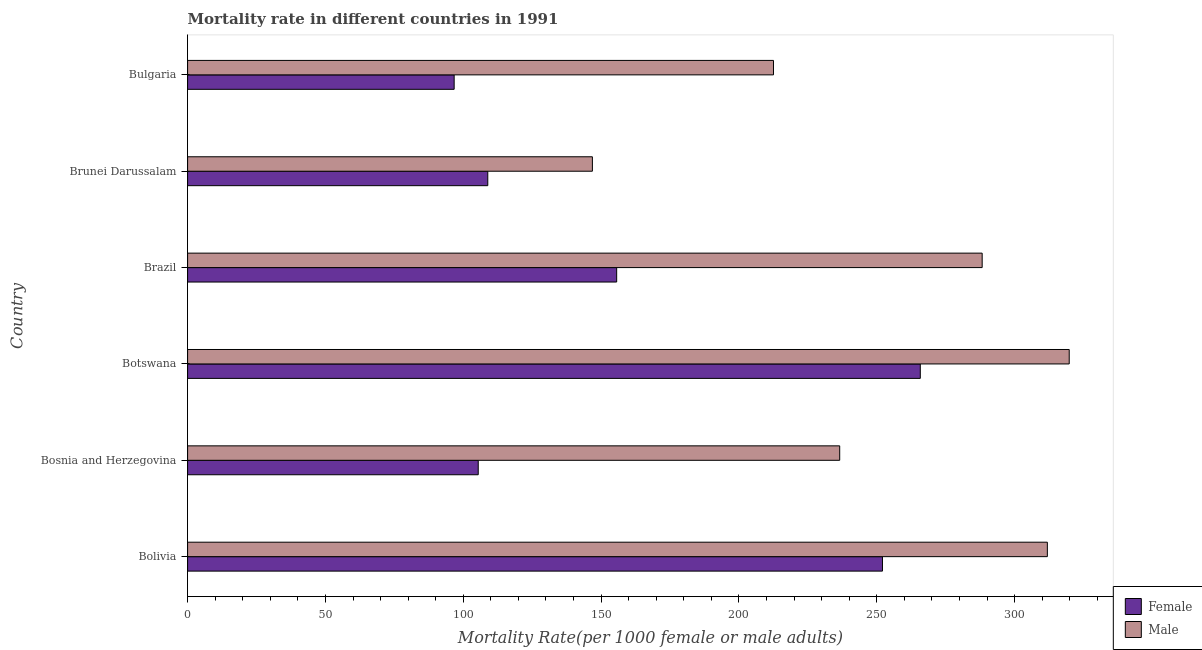How many different coloured bars are there?
Offer a terse response. 2. Are the number of bars per tick equal to the number of legend labels?
Provide a short and direct response. Yes. Are the number of bars on each tick of the Y-axis equal?
Your response must be concise. Yes. How many bars are there on the 1st tick from the top?
Offer a very short reply. 2. How many bars are there on the 1st tick from the bottom?
Your answer should be compact. 2. What is the label of the 6th group of bars from the top?
Offer a terse response. Bolivia. In how many cases, is the number of bars for a given country not equal to the number of legend labels?
Ensure brevity in your answer.  0. What is the male mortality rate in Bosnia and Herzegovina?
Offer a terse response. 236.55. Across all countries, what is the maximum female mortality rate?
Keep it short and to the point. 265.79. Across all countries, what is the minimum female mortality rate?
Offer a terse response. 96.69. In which country was the female mortality rate maximum?
Give a very brief answer. Botswana. In which country was the female mortality rate minimum?
Your answer should be compact. Bulgaria. What is the total male mortality rate in the graph?
Offer a terse response. 1515.84. What is the difference between the female mortality rate in Bolivia and that in Brazil?
Your answer should be compact. 96.42. What is the difference between the male mortality rate in Bulgaria and the female mortality rate in Bosnia and Herzegovina?
Provide a succinct answer. 107.1. What is the average male mortality rate per country?
Provide a succinct answer. 252.64. What is the difference between the female mortality rate and male mortality rate in Brazil?
Your answer should be compact. -132.59. In how many countries, is the female mortality rate greater than 130 ?
Provide a short and direct response. 3. What is the ratio of the female mortality rate in Brunei Darussalam to that in Bulgaria?
Give a very brief answer. 1.13. Is the male mortality rate in Botswana less than that in Brazil?
Give a very brief answer. No. Is the difference between the male mortality rate in Bosnia and Herzegovina and Bulgaria greater than the difference between the female mortality rate in Bosnia and Herzegovina and Bulgaria?
Ensure brevity in your answer.  Yes. What is the difference between the highest and the second highest female mortality rate?
Give a very brief answer. 13.72. What is the difference between the highest and the lowest female mortality rate?
Offer a terse response. 169.09. In how many countries, is the male mortality rate greater than the average male mortality rate taken over all countries?
Offer a very short reply. 3. What does the 1st bar from the bottom in Botswana represents?
Ensure brevity in your answer.  Female. How many bars are there?
Your response must be concise. 12. Are all the bars in the graph horizontal?
Your response must be concise. Yes. How many countries are there in the graph?
Your answer should be very brief. 6. What is the difference between two consecutive major ticks on the X-axis?
Keep it short and to the point. 50. Does the graph contain any zero values?
Offer a very short reply. No. Where does the legend appear in the graph?
Keep it short and to the point. Bottom right. How many legend labels are there?
Make the answer very short. 2. How are the legend labels stacked?
Your answer should be compact. Vertical. What is the title of the graph?
Give a very brief answer. Mortality rate in different countries in 1991. What is the label or title of the X-axis?
Your response must be concise. Mortality Rate(per 1000 female or male adults). What is the label or title of the Y-axis?
Give a very brief answer. Country. What is the Mortality Rate(per 1000 female or male adults) of Female in Bolivia?
Your answer should be very brief. 252.06. What is the Mortality Rate(per 1000 female or male adults) of Male in Bolivia?
Offer a very short reply. 311.88. What is the Mortality Rate(per 1000 female or male adults) of Female in Bosnia and Herzegovina?
Your answer should be compact. 105.43. What is the Mortality Rate(per 1000 female or male adults) of Male in Bosnia and Herzegovina?
Offer a very short reply. 236.55. What is the Mortality Rate(per 1000 female or male adults) of Female in Botswana?
Make the answer very short. 265.79. What is the Mortality Rate(per 1000 female or male adults) in Male in Botswana?
Provide a short and direct response. 319.81. What is the Mortality Rate(per 1000 female or male adults) of Female in Brazil?
Your response must be concise. 155.65. What is the Mortality Rate(per 1000 female or male adults) in Male in Brazil?
Your answer should be compact. 288.23. What is the Mortality Rate(per 1000 female or male adults) of Female in Brunei Darussalam?
Offer a terse response. 108.89. What is the Mortality Rate(per 1000 female or male adults) of Male in Brunei Darussalam?
Make the answer very short. 146.84. What is the Mortality Rate(per 1000 female or male adults) of Female in Bulgaria?
Provide a short and direct response. 96.69. What is the Mortality Rate(per 1000 female or male adults) in Male in Bulgaria?
Your answer should be very brief. 212.53. Across all countries, what is the maximum Mortality Rate(per 1000 female or male adults) in Female?
Provide a succinct answer. 265.79. Across all countries, what is the maximum Mortality Rate(per 1000 female or male adults) in Male?
Give a very brief answer. 319.81. Across all countries, what is the minimum Mortality Rate(per 1000 female or male adults) of Female?
Your response must be concise. 96.69. Across all countries, what is the minimum Mortality Rate(per 1000 female or male adults) of Male?
Ensure brevity in your answer.  146.84. What is the total Mortality Rate(per 1000 female or male adults) in Female in the graph?
Provide a short and direct response. 984.52. What is the total Mortality Rate(per 1000 female or male adults) of Male in the graph?
Your answer should be very brief. 1515.85. What is the difference between the Mortality Rate(per 1000 female or male adults) of Female in Bolivia and that in Bosnia and Herzegovina?
Give a very brief answer. 146.63. What is the difference between the Mortality Rate(per 1000 female or male adults) of Male in Bolivia and that in Bosnia and Herzegovina?
Ensure brevity in your answer.  75.33. What is the difference between the Mortality Rate(per 1000 female or male adults) in Female in Bolivia and that in Botswana?
Offer a terse response. -13.72. What is the difference between the Mortality Rate(per 1000 female or male adults) of Male in Bolivia and that in Botswana?
Give a very brief answer. -7.93. What is the difference between the Mortality Rate(per 1000 female or male adults) of Female in Bolivia and that in Brazil?
Give a very brief answer. 96.42. What is the difference between the Mortality Rate(per 1000 female or male adults) in Male in Bolivia and that in Brazil?
Offer a terse response. 23.64. What is the difference between the Mortality Rate(per 1000 female or male adults) of Female in Bolivia and that in Brunei Darussalam?
Your answer should be compact. 143.18. What is the difference between the Mortality Rate(per 1000 female or male adults) of Male in Bolivia and that in Brunei Darussalam?
Offer a very short reply. 165.04. What is the difference between the Mortality Rate(per 1000 female or male adults) in Female in Bolivia and that in Bulgaria?
Make the answer very short. 155.37. What is the difference between the Mortality Rate(per 1000 female or male adults) in Male in Bolivia and that in Bulgaria?
Provide a short and direct response. 99.35. What is the difference between the Mortality Rate(per 1000 female or male adults) of Female in Bosnia and Herzegovina and that in Botswana?
Make the answer very short. -160.36. What is the difference between the Mortality Rate(per 1000 female or male adults) of Male in Bosnia and Herzegovina and that in Botswana?
Offer a very short reply. -83.26. What is the difference between the Mortality Rate(per 1000 female or male adults) in Female in Bosnia and Herzegovina and that in Brazil?
Provide a short and direct response. -50.22. What is the difference between the Mortality Rate(per 1000 female or male adults) in Male in Bosnia and Herzegovina and that in Brazil?
Keep it short and to the point. -51.68. What is the difference between the Mortality Rate(per 1000 female or male adults) of Female in Bosnia and Herzegovina and that in Brunei Darussalam?
Give a very brief answer. -3.46. What is the difference between the Mortality Rate(per 1000 female or male adults) of Male in Bosnia and Herzegovina and that in Brunei Darussalam?
Offer a very short reply. 89.71. What is the difference between the Mortality Rate(per 1000 female or male adults) in Female in Bosnia and Herzegovina and that in Bulgaria?
Provide a succinct answer. 8.74. What is the difference between the Mortality Rate(per 1000 female or male adults) in Male in Bosnia and Herzegovina and that in Bulgaria?
Provide a succinct answer. 24.02. What is the difference between the Mortality Rate(per 1000 female or male adults) of Female in Botswana and that in Brazil?
Give a very brief answer. 110.14. What is the difference between the Mortality Rate(per 1000 female or male adults) of Male in Botswana and that in Brazil?
Provide a succinct answer. 31.58. What is the difference between the Mortality Rate(per 1000 female or male adults) of Female in Botswana and that in Brunei Darussalam?
Your answer should be compact. 156.9. What is the difference between the Mortality Rate(per 1000 female or male adults) of Male in Botswana and that in Brunei Darussalam?
Your response must be concise. 172.97. What is the difference between the Mortality Rate(per 1000 female or male adults) of Female in Botswana and that in Bulgaria?
Make the answer very short. 169.09. What is the difference between the Mortality Rate(per 1000 female or male adults) of Male in Botswana and that in Bulgaria?
Provide a short and direct response. 107.28. What is the difference between the Mortality Rate(per 1000 female or male adults) in Female in Brazil and that in Brunei Darussalam?
Ensure brevity in your answer.  46.76. What is the difference between the Mortality Rate(per 1000 female or male adults) of Male in Brazil and that in Brunei Darussalam?
Give a very brief answer. 141.39. What is the difference between the Mortality Rate(per 1000 female or male adults) in Female in Brazil and that in Bulgaria?
Ensure brevity in your answer.  58.95. What is the difference between the Mortality Rate(per 1000 female or male adults) in Male in Brazil and that in Bulgaria?
Offer a terse response. 75.7. What is the difference between the Mortality Rate(per 1000 female or male adults) in Female in Brunei Darussalam and that in Bulgaria?
Ensure brevity in your answer.  12.2. What is the difference between the Mortality Rate(per 1000 female or male adults) of Male in Brunei Darussalam and that in Bulgaria?
Give a very brief answer. -65.69. What is the difference between the Mortality Rate(per 1000 female or male adults) in Female in Bolivia and the Mortality Rate(per 1000 female or male adults) in Male in Bosnia and Herzegovina?
Your answer should be compact. 15.51. What is the difference between the Mortality Rate(per 1000 female or male adults) in Female in Bolivia and the Mortality Rate(per 1000 female or male adults) in Male in Botswana?
Provide a short and direct response. -67.75. What is the difference between the Mortality Rate(per 1000 female or male adults) of Female in Bolivia and the Mortality Rate(per 1000 female or male adults) of Male in Brazil?
Your response must be concise. -36.17. What is the difference between the Mortality Rate(per 1000 female or male adults) of Female in Bolivia and the Mortality Rate(per 1000 female or male adults) of Male in Brunei Darussalam?
Offer a very short reply. 105.22. What is the difference between the Mortality Rate(per 1000 female or male adults) of Female in Bolivia and the Mortality Rate(per 1000 female or male adults) of Male in Bulgaria?
Your answer should be compact. 39.54. What is the difference between the Mortality Rate(per 1000 female or male adults) in Female in Bosnia and Herzegovina and the Mortality Rate(per 1000 female or male adults) in Male in Botswana?
Your answer should be compact. -214.38. What is the difference between the Mortality Rate(per 1000 female or male adults) of Female in Bosnia and Herzegovina and the Mortality Rate(per 1000 female or male adults) of Male in Brazil?
Offer a terse response. -182.8. What is the difference between the Mortality Rate(per 1000 female or male adults) in Female in Bosnia and Herzegovina and the Mortality Rate(per 1000 female or male adults) in Male in Brunei Darussalam?
Make the answer very short. -41.41. What is the difference between the Mortality Rate(per 1000 female or male adults) in Female in Bosnia and Herzegovina and the Mortality Rate(per 1000 female or male adults) in Male in Bulgaria?
Offer a terse response. -107.1. What is the difference between the Mortality Rate(per 1000 female or male adults) of Female in Botswana and the Mortality Rate(per 1000 female or male adults) of Male in Brazil?
Your answer should be very brief. -22.44. What is the difference between the Mortality Rate(per 1000 female or male adults) of Female in Botswana and the Mortality Rate(per 1000 female or male adults) of Male in Brunei Darussalam?
Your answer should be very brief. 118.95. What is the difference between the Mortality Rate(per 1000 female or male adults) in Female in Botswana and the Mortality Rate(per 1000 female or male adults) in Male in Bulgaria?
Your answer should be compact. 53.26. What is the difference between the Mortality Rate(per 1000 female or male adults) in Female in Brazil and the Mortality Rate(per 1000 female or male adults) in Male in Brunei Darussalam?
Give a very brief answer. 8.81. What is the difference between the Mortality Rate(per 1000 female or male adults) of Female in Brazil and the Mortality Rate(per 1000 female or male adults) of Male in Bulgaria?
Ensure brevity in your answer.  -56.88. What is the difference between the Mortality Rate(per 1000 female or male adults) in Female in Brunei Darussalam and the Mortality Rate(per 1000 female or male adults) in Male in Bulgaria?
Offer a very short reply. -103.64. What is the average Mortality Rate(per 1000 female or male adults) of Female per country?
Offer a terse response. 164.09. What is the average Mortality Rate(per 1000 female or male adults) of Male per country?
Your answer should be very brief. 252.64. What is the difference between the Mortality Rate(per 1000 female or male adults) of Female and Mortality Rate(per 1000 female or male adults) of Male in Bolivia?
Make the answer very short. -59.81. What is the difference between the Mortality Rate(per 1000 female or male adults) in Female and Mortality Rate(per 1000 female or male adults) in Male in Bosnia and Herzegovina?
Your answer should be compact. -131.12. What is the difference between the Mortality Rate(per 1000 female or male adults) of Female and Mortality Rate(per 1000 female or male adults) of Male in Botswana?
Offer a very short reply. -54.02. What is the difference between the Mortality Rate(per 1000 female or male adults) of Female and Mortality Rate(per 1000 female or male adults) of Male in Brazil?
Provide a succinct answer. -132.59. What is the difference between the Mortality Rate(per 1000 female or male adults) of Female and Mortality Rate(per 1000 female or male adults) of Male in Brunei Darussalam?
Offer a terse response. -37.95. What is the difference between the Mortality Rate(per 1000 female or male adults) of Female and Mortality Rate(per 1000 female or male adults) of Male in Bulgaria?
Ensure brevity in your answer.  -115.83. What is the ratio of the Mortality Rate(per 1000 female or male adults) of Female in Bolivia to that in Bosnia and Herzegovina?
Make the answer very short. 2.39. What is the ratio of the Mortality Rate(per 1000 female or male adults) of Male in Bolivia to that in Bosnia and Herzegovina?
Provide a short and direct response. 1.32. What is the ratio of the Mortality Rate(per 1000 female or male adults) in Female in Bolivia to that in Botswana?
Your answer should be very brief. 0.95. What is the ratio of the Mortality Rate(per 1000 female or male adults) of Male in Bolivia to that in Botswana?
Your answer should be compact. 0.98. What is the ratio of the Mortality Rate(per 1000 female or male adults) of Female in Bolivia to that in Brazil?
Your answer should be compact. 1.62. What is the ratio of the Mortality Rate(per 1000 female or male adults) in Male in Bolivia to that in Brazil?
Ensure brevity in your answer.  1.08. What is the ratio of the Mortality Rate(per 1000 female or male adults) of Female in Bolivia to that in Brunei Darussalam?
Ensure brevity in your answer.  2.31. What is the ratio of the Mortality Rate(per 1000 female or male adults) in Male in Bolivia to that in Brunei Darussalam?
Provide a short and direct response. 2.12. What is the ratio of the Mortality Rate(per 1000 female or male adults) in Female in Bolivia to that in Bulgaria?
Make the answer very short. 2.61. What is the ratio of the Mortality Rate(per 1000 female or male adults) of Male in Bolivia to that in Bulgaria?
Provide a short and direct response. 1.47. What is the ratio of the Mortality Rate(per 1000 female or male adults) of Female in Bosnia and Herzegovina to that in Botswana?
Your response must be concise. 0.4. What is the ratio of the Mortality Rate(per 1000 female or male adults) in Male in Bosnia and Herzegovina to that in Botswana?
Make the answer very short. 0.74. What is the ratio of the Mortality Rate(per 1000 female or male adults) of Female in Bosnia and Herzegovina to that in Brazil?
Your answer should be compact. 0.68. What is the ratio of the Mortality Rate(per 1000 female or male adults) of Male in Bosnia and Herzegovina to that in Brazil?
Your response must be concise. 0.82. What is the ratio of the Mortality Rate(per 1000 female or male adults) in Female in Bosnia and Herzegovina to that in Brunei Darussalam?
Keep it short and to the point. 0.97. What is the ratio of the Mortality Rate(per 1000 female or male adults) of Male in Bosnia and Herzegovina to that in Brunei Darussalam?
Offer a very short reply. 1.61. What is the ratio of the Mortality Rate(per 1000 female or male adults) of Female in Bosnia and Herzegovina to that in Bulgaria?
Offer a terse response. 1.09. What is the ratio of the Mortality Rate(per 1000 female or male adults) of Male in Bosnia and Herzegovina to that in Bulgaria?
Your answer should be very brief. 1.11. What is the ratio of the Mortality Rate(per 1000 female or male adults) of Female in Botswana to that in Brazil?
Make the answer very short. 1.71. What is the ratio of the Mortality Rate(per 1000 female or male adults) in Male in Botswana to that in Brazil?
Give a very brief answer. 1.11. What is the ratio of the Mortality Rate(per 1000 female or male adults) in Female in Botswana to that in Brunei Darussalam?
Ensure brevity in your answer.  2.44. What is the ratio of the Mortality Rate(per 1000 female or male adults) of Male in Botswana to that in Brunei Darussalam?
Your answer should be very brief. 2.18. What is the ratio of the Mortality Rate(per 1000 female or male adults) of Female in Botswana to that in Bulgaria?
Keep it short and to the point. 2.75. What is the ratio of the Mortality Rate(per 1000 female or male adults) in Male in Botswana to that in Bulgaria?
Provide a succinct answer. 1.5. What is the ratio of the Mortality Rate(per 1000 female or male adults) in Female in Brazil to that in Brunei Darussalam?
Make the answer very short. 1.43. What is the ratio of the Mortality Rate(per 1000 female or male adults) in Male in Brazil to that in Brunei Darussalam?
Your response must be concise. 1.96. What is the ratio of the Mortality Rate(per 1000 female or male adults) in Female in Brazil to that in Bulgaria?
Your answer should be very brief. 1.61. What is the ratio of the Mortality Rate(per 1000 female or male adults) of Male in Brazil to that in Bulgaria?
Your answer should be compact. 1.36. What is the ratio of the Mortality Rate(per 1000 female or male adults) of Female in Brunei Darussalam to that in Bulgaria?
Make the answer very short. 1.13. What is the ratio of the Mortality Rate(per 1000 female or male adults) of Male in Brunei Darussalam to that in Bulgaria?
Ensure brevity in your answer.  0.69. What is the difference between the highest and the second highest Mortality Rate(per 1000 female or male adults) of Female?
Provide a succinct answer. 13.72. What is the difference between the highest and the second highest Mortality Rate(per 1000 female or male adults) in Male?
Your response must be concise. 7.93. What is the difference between the highest and the lowest Mortality Rate(per 1000 female or male adults) in Female?
Give a very brief answer. 169.09. What is the difference between the highest and the lowest Mortality Rate(per 1000 female or male adults) of Male?
Your answer should be very brief. 172.97. 